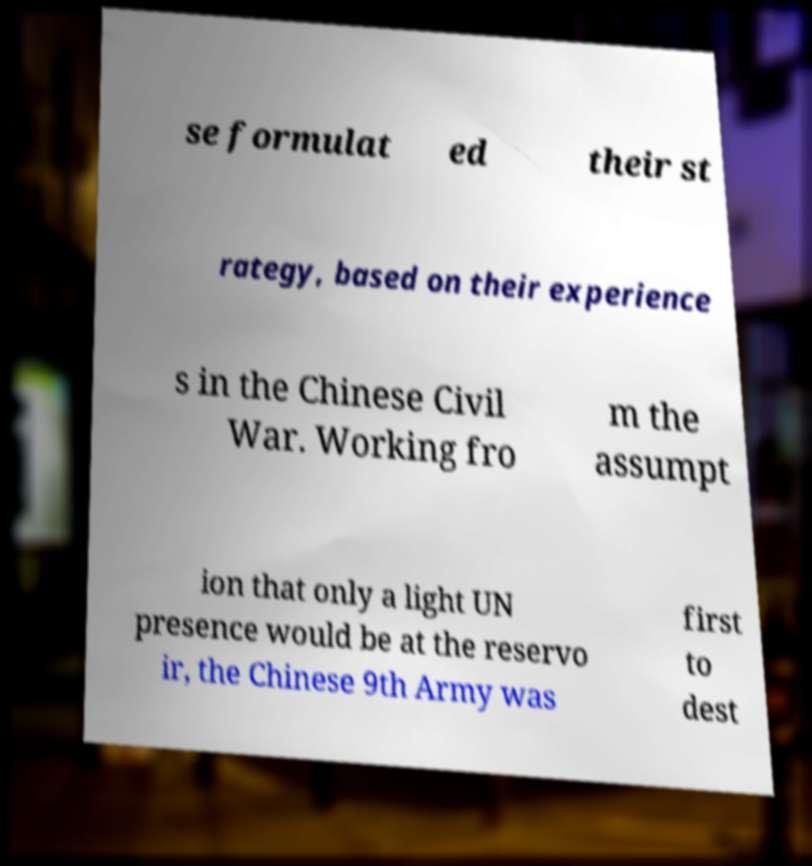Please read and relay the text visible in this image. What does it say? se formulat ed their st rategy, based on their experience s in the Chinese Civil War. Working fro m the assumpt ion that only a light UN presence would be at the reservo ir, the Chinese 9th Army was first to dest 